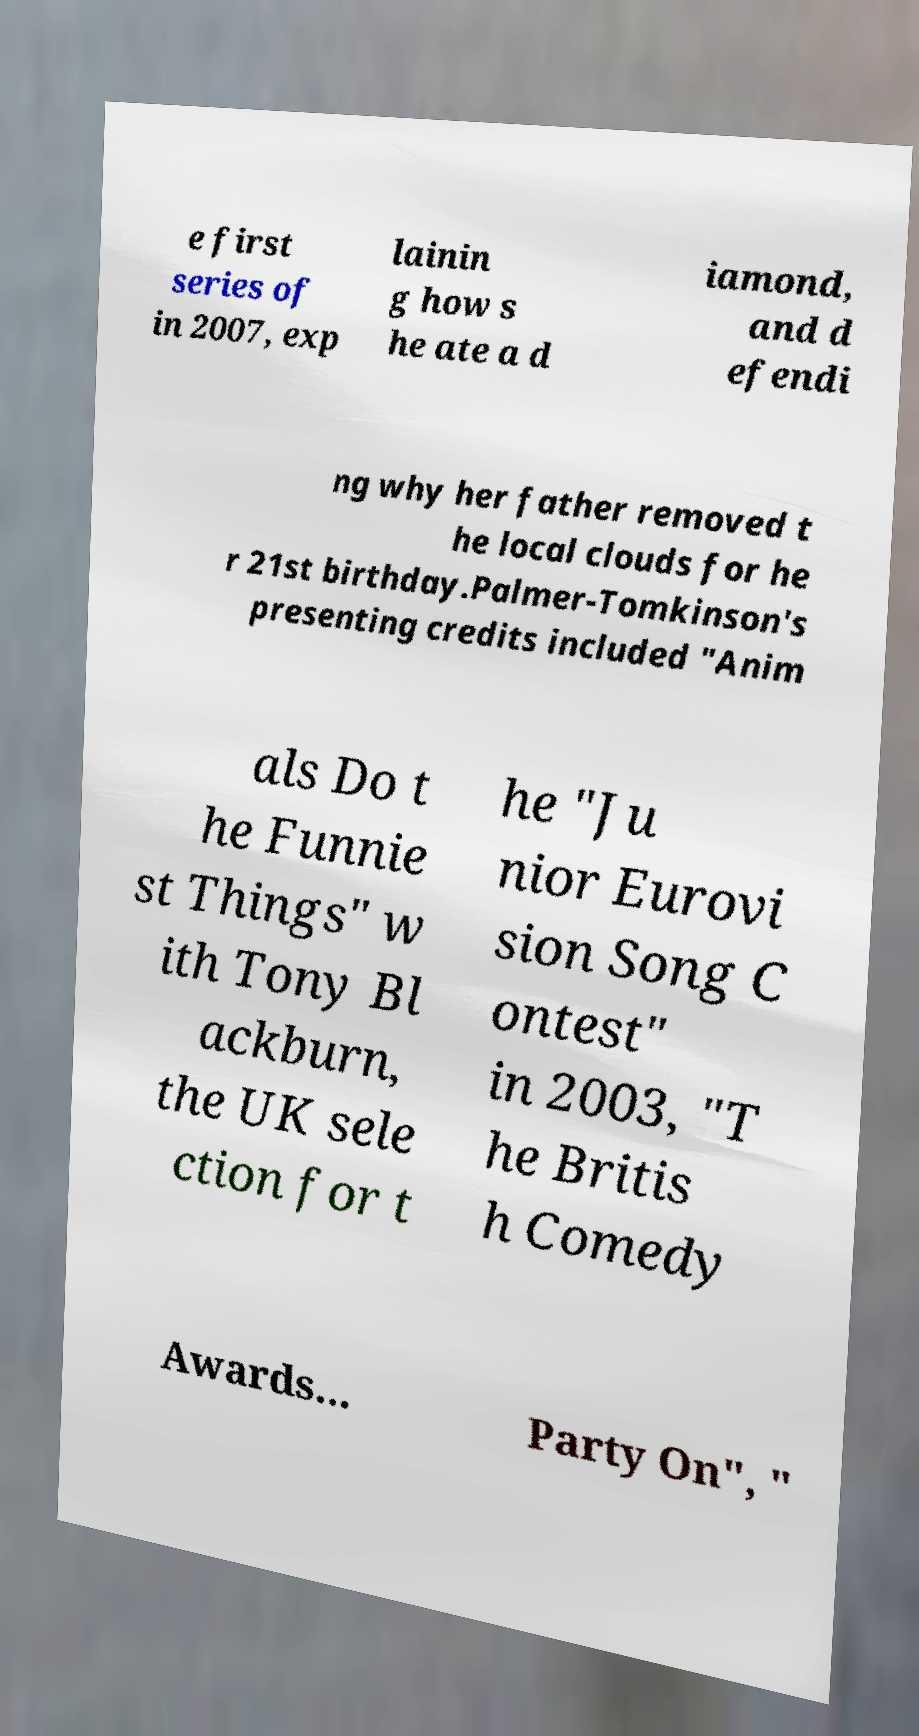Could you extract and type out the text from this image? e first series of in 2007, exp lainin g how s he ate a d iamond, and d efendi ng why her father removed t he local clouds for he r 21st birthday.Palmer-Tomkinson's presenting credits included "Anim als Do t he Funnie st Things" w ith Tony Bl ackburn, the UK sele ction for t he "Ju nior Eurovi sion Song C ontest" in 2003, "T he Britis h Comedy Awards... Party On", " 